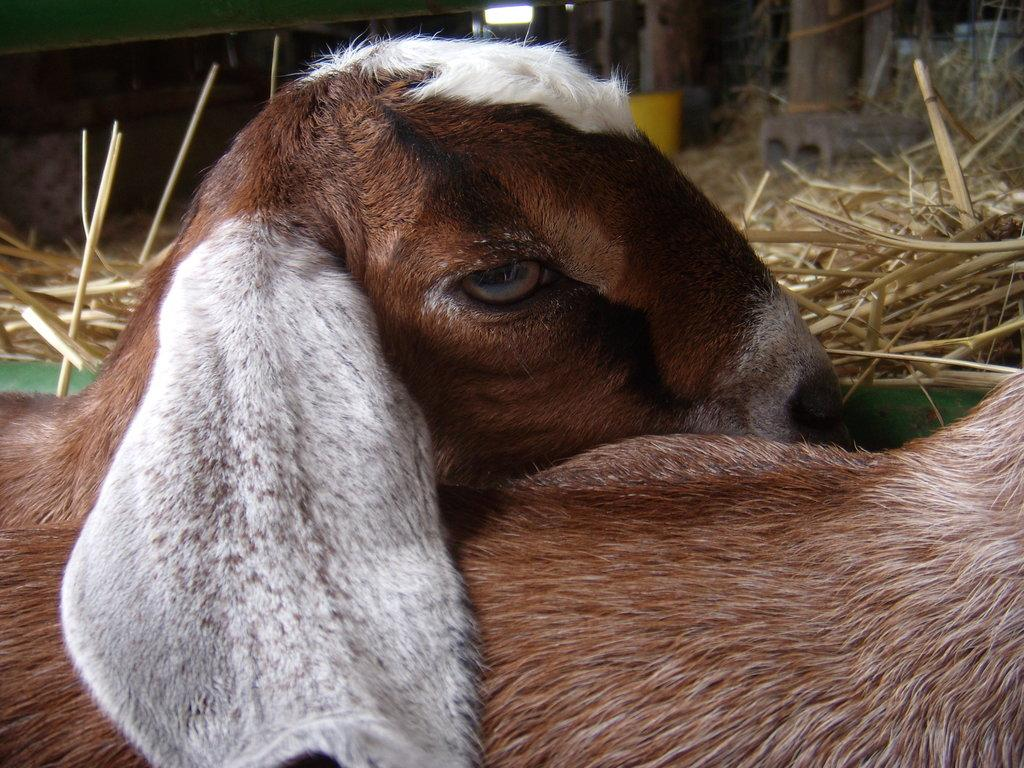How many animals are present in the image? There are two animals in the image. What can be seen in the background of the image? There are poles and grass in the background of the image. Are there any other objects visible in the background? Yes, there are other objects visible in the background of the image. What level of wealth can be determined from the image? There is no information in the image to determine the level of wealth of the animals or their surroundings. 